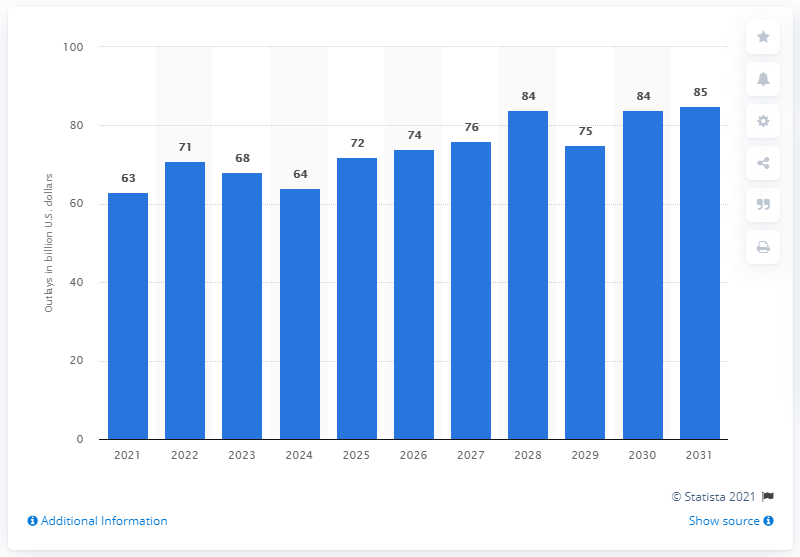Point out several critical features in this image. The expected increase in the amount of the military retirement trust fund by 2031 is 85%. It is estimated that $63 million will be spent on the military retirement trust fund in 2021. The total outlays of the military retirement trust fund are estimated to be approximately 63 billion U.S. dollars in the year 2021. 